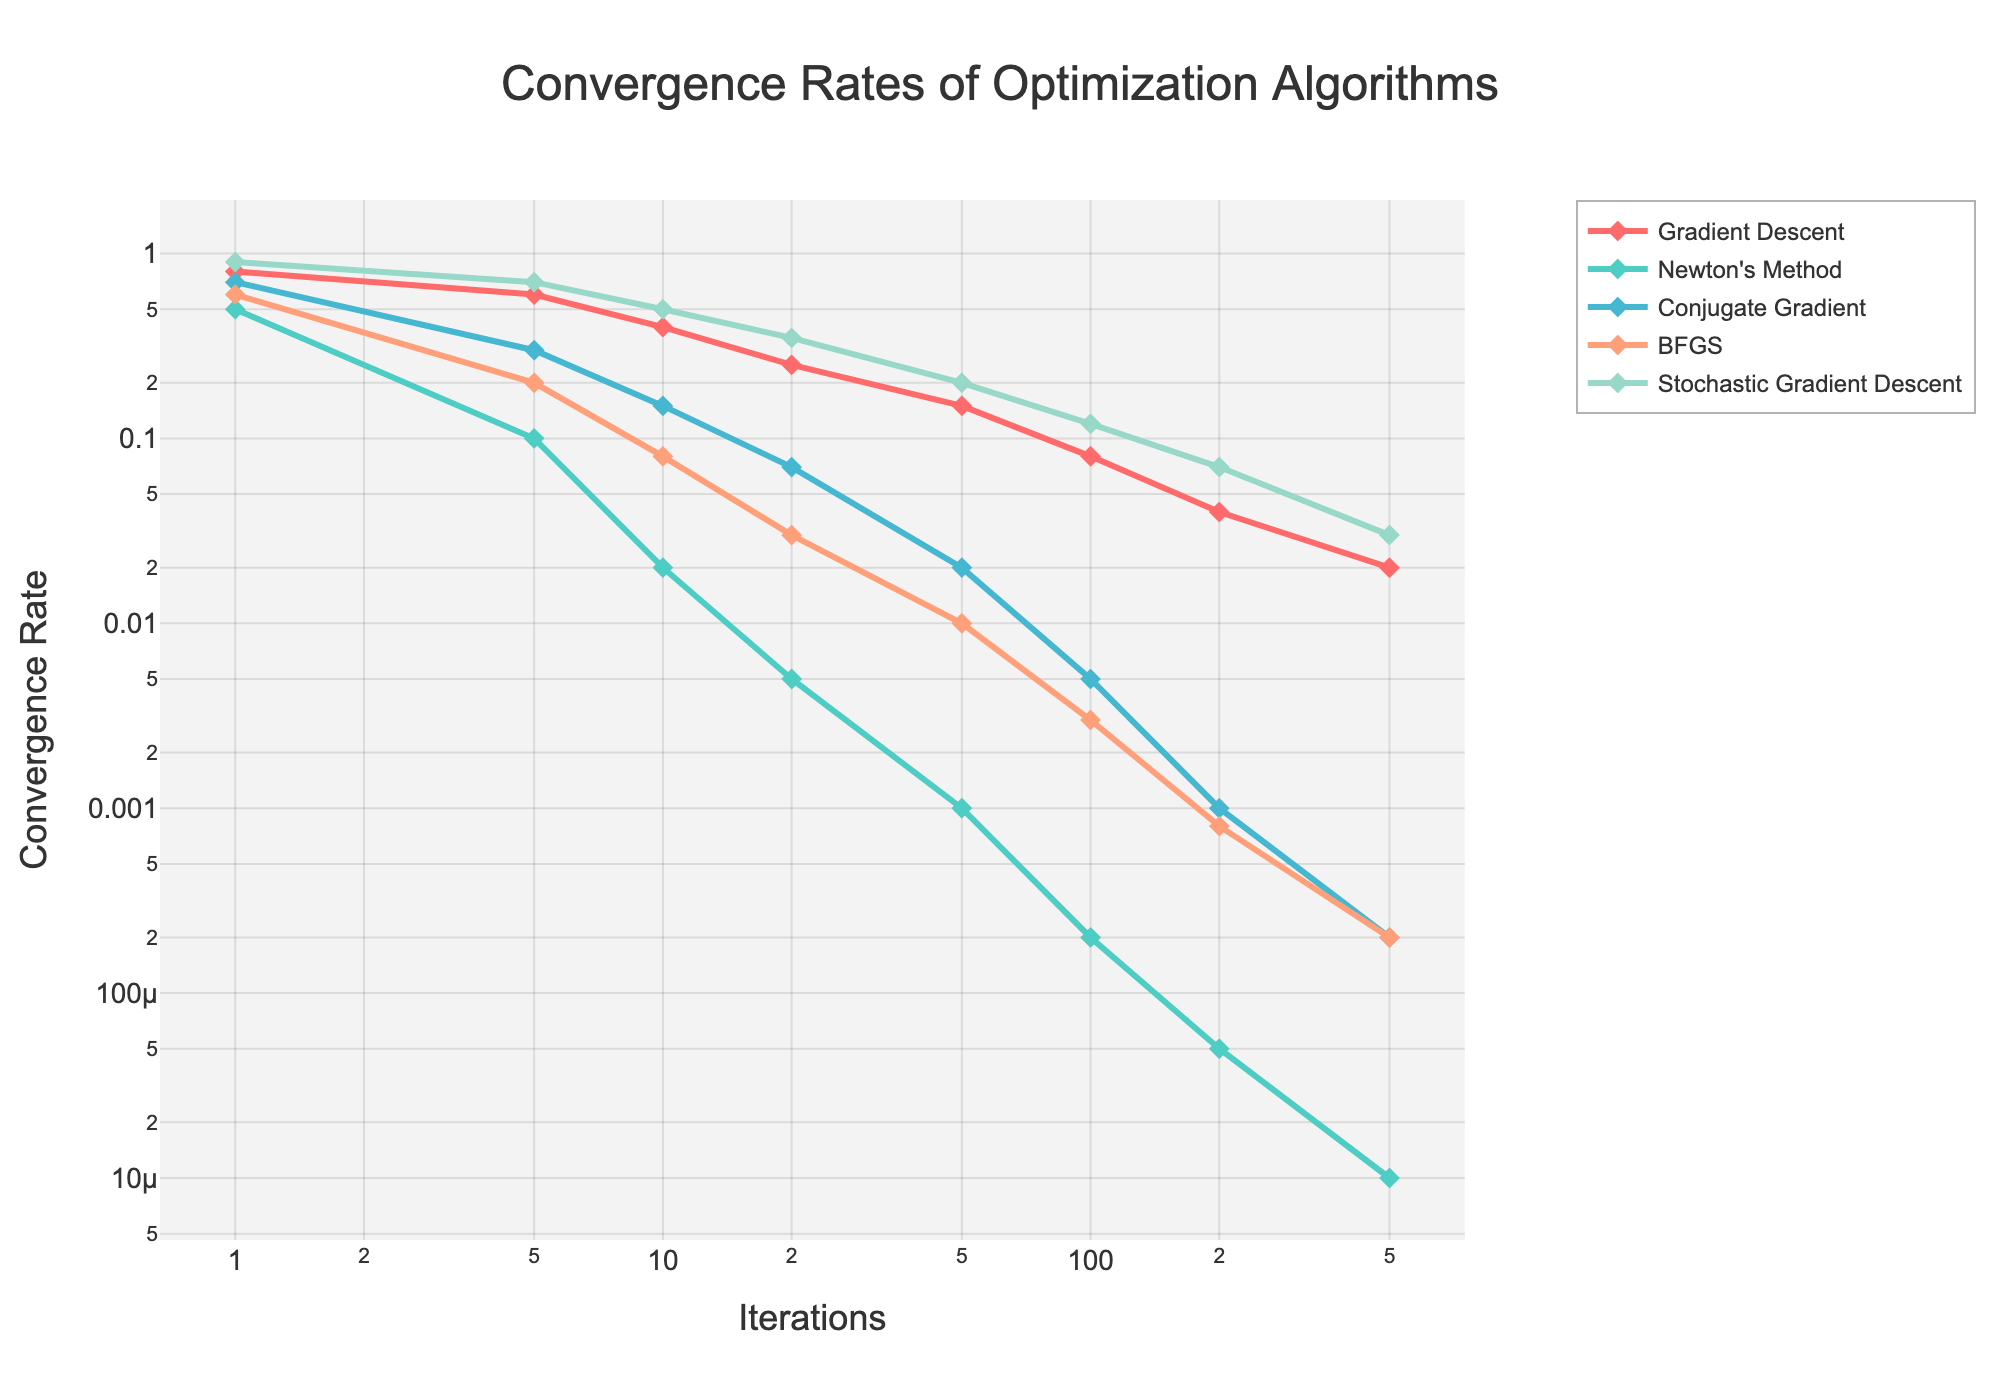What's the convergence rate of Gradient Descent at iteration 50? From the figure, locate the curve for Gradient Descent and find the point where the iteration is 50. The convergence rate at this point is given on the y-axis.
Answer: 0.15 Which algorithm has the fastest convergence rate at iteration 10? Compare the convergence rates of all algorithms at iteration 10. The curve with the lowest convergence rate value represents the fastest convergence.
Answer: Newton's Method Between iterations 1 and 10, which algorithm shows the greatest improvement in convergence rate? Calculate the difference in convergence rates between iterations 1 and 10 for each algorithm. The algorithm with the largest difference shows the greatest improvement.
Answer: Newton's Method By how much does the convergence rate for Conjugate Gradient decrease from iteration 20 to 50? Locate the convergence rates of Conjugate Gradient at iterations 20 and 50, then subtract the value at iteration 50 from the value at iteration 20.
Answer: 0.05 Which algorithm has the least change in convergence rate between iterations 10 and 20? Calculate the absolute difference in convergence rate between iterations 10 and 20 for each algorithm. The algorithm with the smallest difference has the least change.
Answer: Newton's Method At iteration 100, how does the convergence rate of Stochastic Gradient Descent compare to BFGS? Compare the convergence rates of Stochastic Gradient Descent and BFGS at iteration 100. Determine which one is higher.
Answer: Stochastic Gradient Descent's rate is higher Is the convergence rate trend for BFGS steeper than that of Gradient Descent? Evaluate the slope of the curves for BFGS and Gradient Descent. A steeper drop indicates a steeper trend.
Answer: Yes What color is used for the Newton's Method line in the plot? Visually identify the color used for the curve representing Newton's Method.
Answer: Light blue How does the performance of Conjugate Gradient at iteration 500 compare to Gradient Descent at the same iteration? Compare the convergence rates of Conjugate Gradient and Gradient Descent at iteration 500. The algorithm with a lower rate performs better.
Answer: Conjugate Gradient performs better 